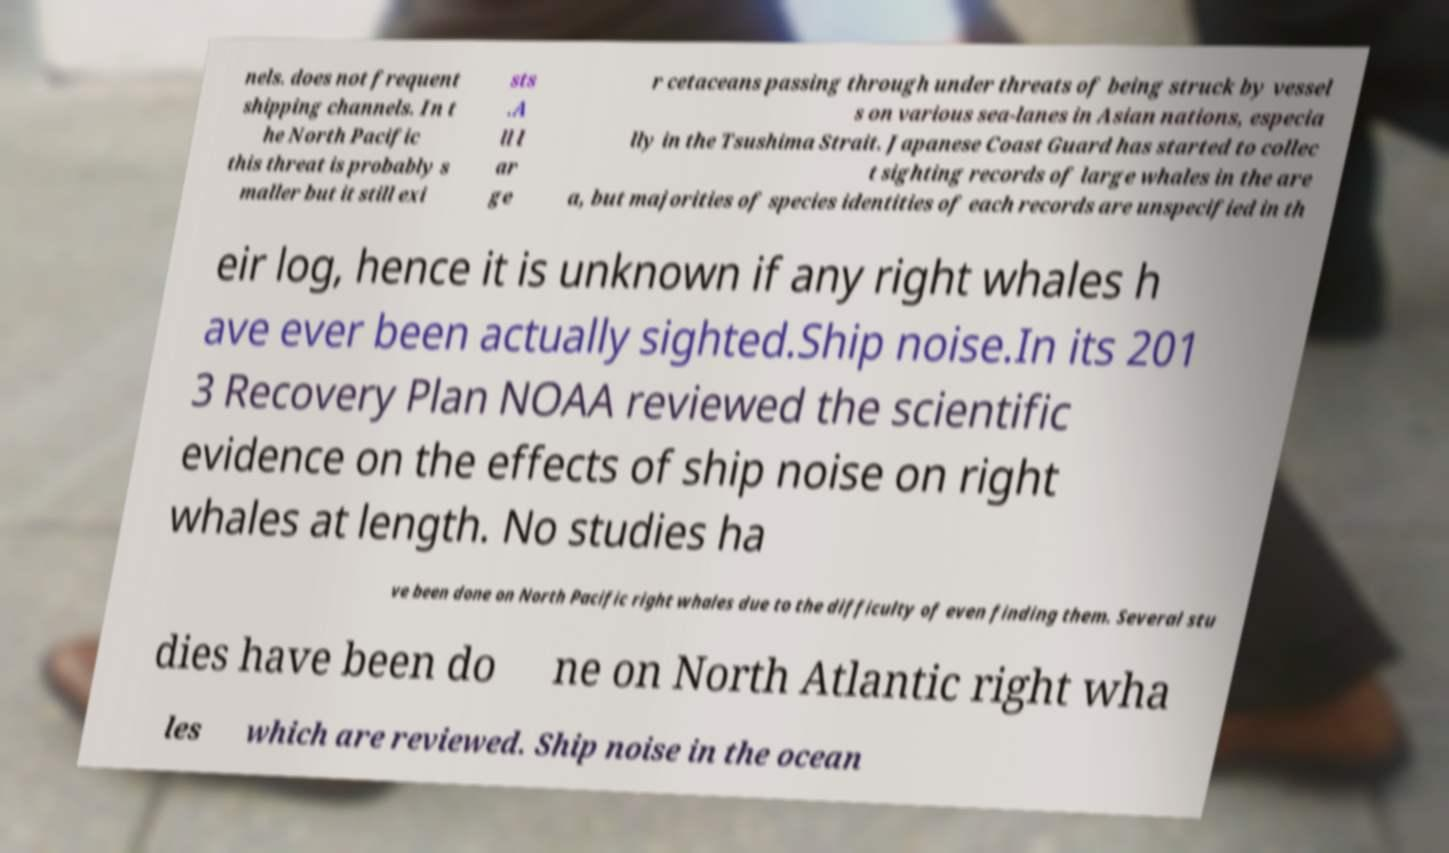Could you extract and type out the text from this image? nels. does not frequent shipping channels. In t he North Pacific this threat is probably s maller but it still exi sts .A ll l ar ge r cetaceans passing through under threats of being struck by vessel s on various sea-lanes in Asian nations, especia lly in the Tsushima Strait. Japanese Coast Guard has started to collec t sighting records of large whales in the are a, but majorities of species identities of each records are unspecified in th eir log, hence it is unknown if any right whales h ave ever been actually sighted.Ship noise.In its 201 3 Recovery Plan NOAA reviewed the scientific evidence on the effects of ship noise on right whales at length. No studies ha ve been done on North Pacific right whales due to the difficulty of even finding them. Several stu dies have been do ne on North Atlantic right wha les which are reviewed. Ship noise in the ocean 